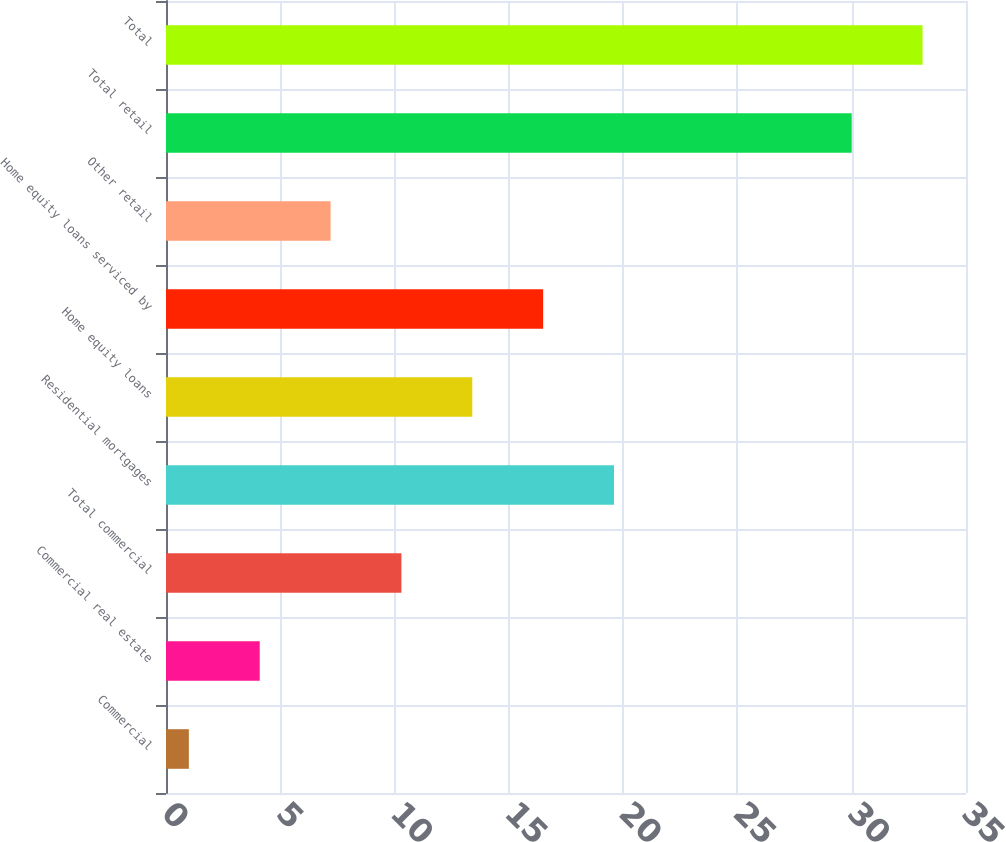Convert chart. <chart><loc_0><loc_0><loc_500><loc_500><bar_chart><fcel>Commercial<fcel>Commercial real estate<fcel>Total commercial<fcel>Residential mortgages<fcel>Home equity loans<fcel>Home equity loans serviced by<fcel>Other retail<fcel>Total retail<fcel>Total<nl><fcel>1<fcel>4.1<fcel>10.3<fcel>19.6<fcel>13.4<fcel>16.5<fcel>7.2<fcel>30<fcel>33.1<nl></chart> 